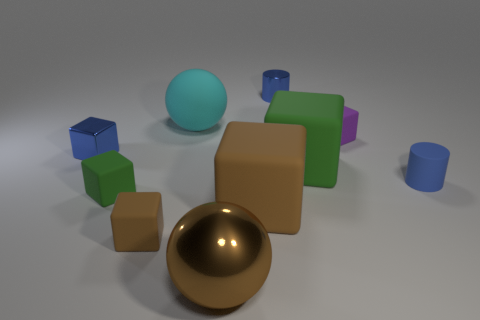Subtract 1 cubes. How many cubes are left? 5 Subtract all blue blocks. How many blocks are left? 5 Subtract all purple cubes. How many cubes are left? 5 Subtract all blue blocks. Subtract all blue cylinders. How many blocks are left? 5 Subtract all cylinders. How many objects are left? 8 Add 1 brown matte objects. How many brown matte objects are left? 3 Add 8 blue metallic cylinders. How many blue metallic cylinders exist? 9 Subtract 0 gray cubes. How many objects are left? 10 Subtract all cubes. Subtract all purple matte blocks. How many objects are left? 3 